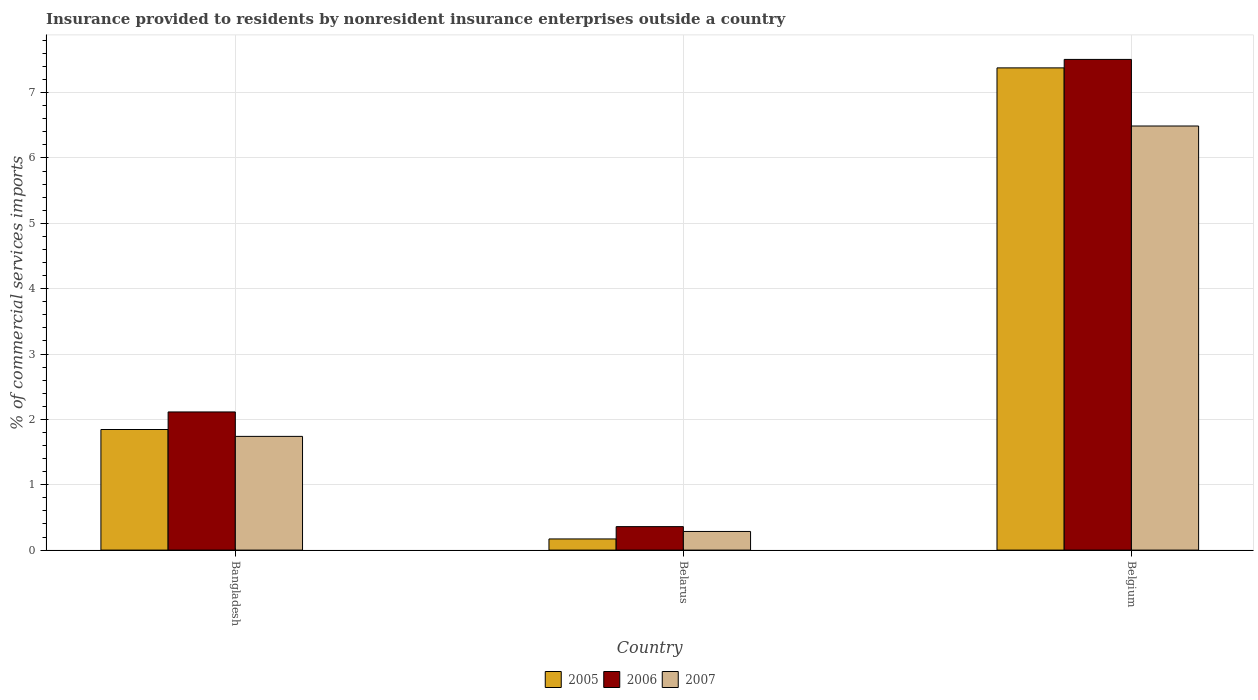How many different coloured bars are there?
Your answer should be very brief. 3. How many groups of bars are there?
Provide a succinct answer. 3. Are the number of bars on each tick of the X-axis equal?
Make the answer very short. Yes. How many bars are there on the 3rd tick from the left?
Your answer should be compact. 3. How many bars are there on the 2nd tick from the right?
Provide a succinct answer. 3. What is the label of the 2nd group of bars from the left?
Your response must be concise. Belarus. What is the Insurance provided to residents in 2007 in Bangladesh?
Provide a succinct answer. 1.74. Across all countries, what is the maximum Insurance provided to residents in 2006?
Provide a short and direct response. 7.51. Across all countries, what is the minimum Insurance provided to residents in 2006?
Keep it short and to the point. 0.36. In which country was the Insurance provided to residents in 2007 minimum?
Give a very brief answer. Belarus. What is the total Insurance provided to residents in 2005 in the graph?
Provide a short and direct response. 9.39. What is the difference between the Insurance provided to residents in 2006 in Bangladesh and that in Belarus?
Keep it short and to the point. 1.75. What is the difference between the Insurance provided to residents in 2006 in Bangladesh and the Insurance provided to residents in 2005 in Belgium?
Provide a short and direct response. -5.26. What is the average Insurance provided to residents in 2005 per country?
Give a very brief answer. 3.13. What is the difference between the Insurance provided to residents of/in 2007 and Insurance provided to residents of/in 2006 in Belarus?
Ensure brevity in your answer.  -0.07. What is the ratio of the Insurance provided to residents in 2005 in Belarus to that in Belgium?
Give a very brief answer. 0.02. Is the Insurance provided to residents in 2007 in Bangladesh less than that in Belgium?
Ensure brevity in your answer.  Yes. What is the difference between the highest and the second highest Insurance provided to residents in 2005?
Give a very brief answer. -1.67. What is the difference between the highest and the lowest Insurance provided to residents in 2007?
Ensure brevity in your answer.  6.2. Is the sum of the Insurance provided to residents in 2007 in Bangladesh and Belarus greater than the maximum Insurance provided to residents in 2005 across all countries?
Provide a short and direct response. No. What does the 3rd bar from the right in Belarus represents?
Offer a very short reply. 2005. Is it the case that in every country, the sum of the Insurance provided to residents in 2006 and Insurance provided to residents in 2005 is greater than the Insurance provided to residents in 2007?
Offer a very short reply. Yes. How many bars are there?
Your answer should be compact. 9. Are all the bars in the graph horizontal?
Your answer should be very brief. No. Are the values on the major ticks of Y-axis written in scientific E-notation?
Your response must be concise. No. Where does the legend appear in the graph?
Provide a short and direct response. Bottom center. How many legend labels are there?
Your answer should be compact. 3. How are the legend labels stacked?
Your response must be concise. Horizontal. What is the title of the graph?
Offer a very short reply. Insurance provided to residents by nonresident insurance enterprises outside a country. Does "1995" appear as one of the legend labels in the graph?
Your answer should be very brief. No. What is the label or title of the X-axis?
Your answer should be very brief. Country. What is the label or title of the Y-axis?
Make the answer very short. % of commercial services imports. What is the % of commercial services imports of 2005 in Bangladesh?
Your answer should be very brief. 1.85. What is the % of commercial services imports in 2006 in Bangladesh?
Provide a succinct answer. 2.11. What is the % of commercial services imports in 2007 in Bangladesh?
Give a very brief answer. 1.74. What is the % of commercial services imports of 2005 in Belarus?
Provide a short and direct response. 0.17. What is the % of commercial services imports of 2006 in Belarus?
Give a very brief answer. 0.36. What is the % of commercial services imports of 2007 in Belarus?
Provide a succinct answer. 0.29. What is the % of commercial services imports in 2005 in Belgium?
Your response must be concise. 7.38. What is the % of commercial services imports in 2006 in Belgium?
Offer a terse response. 7.51. What is the % of commercial services imports of 2007 in Belgium?
Offer a terse response. 6.49. Across all countries, what is the maximum % of commercial services imports in 2005?
Keep it short and to the point. 7.38. Across all countries, what is the maximum % of commercial services imports in 2006?
Provide a succinct answer. 7.51. Across all countries, what is the maximum % of commercial services imports of 2007?
Your answer should be compact. 6.49. Across all countries, what is the minimum % of commercial services imports in 2005?
Provide a short and direct response. 0.17. Across all countries, what is the minimum % of commercial services imports of 2006?
Provide a succinct answer. 0.36. Across all countries, what is the minimum % of commercial services imports of 2007?
Your response must be concise. 0.29. What is the total % of commercial services imports in 2005 in the graph?
Ensure brevity in your answer.  9.39. What is the total % of commercial services imports in 2006 in the graph?
Provide a short and direct response. 9.98. What is the total % of commercial services imports of 2007 in the graph?
Give a very brief answer. 8.51. What is the difference between the % of commercial services imports in 2005 in Bangladesh and that in Belarus?
Your answer should be very brief. 1.67. What is the difference between the % of commercial services imports of 2006 in Bangladesh and that in Belarus?
Your response must be concise. 1.75. What is the difference between the % of commercial services imports of 2007 in Bangladesh and that in Belarus?
Provide a short and direct response. 1.45. What is the difference between the % of commercial services imports in 2005 in Bangladesh and that in Belgium?
Make the answer very short. -5.53. What is the difference between the % of commercial services imports in 2006 in Bangladesh and that in Belgium?
Keep it short and to the point. -5.39. What is the difference between the % of commercial services imports of 2007 in Bangladesh and that in Belgium?
Your response must be concise. -4.75. What is the difference between the % of commercial services imports in 2005 in Belarus and that in Belgium?
Ensure brevity in your answer.  -7.21. What is the difference between the % of commercial services imports of 2006 in Belarus and that in Belgium?
Your response must be concise. -7.15. What is the difference between the % of commercial services imports of 2007 in Belarus and that in Belgium?
Provide a short and direct response. -6.2. What is the difference between the % of commercial services imports in 2005 in Bangladesh and the % of commercial services imports in 2006 in Belarus?
Provide a succinct answer. 1.49. What is the difference between the % of commercial services imports in 2005 in Bangladesh and the % of commercial services imports in 2007 in Belarus?
Your answer should be very brief. 1.56. What is the difference between the % of commercial services imports of 2006 in Bangladesh and the % of commercial services imports of 2007 in Belarus?
Your response must be concise. 1.83. What is the difference between the % of commercial services imports of 2005 in Bangladesh and the % of commercial services imports of 2006 in Belgium?
Your answer should be very brief. -5.66. What is the difference between the % of commercial services imports in 2005 in Bangladesh and the % of commercial services imports in 2007 in Belgium?
Your answer should be compact. -4.64. What is the difference between the % of commercial services imports of 2006 in Bangladesh and the % of commercial services imports of 2007 in Belgium?
Offer a very short reply. -4.38. What is the difference between the % of commercial services imports in 2005 in Belarus and the % of commercial services imports in 2006 in Belgium?
Give a very brief answer. -7.34. What is the difference between the % of commercial services imports of 2005 in Belarus and the % of commercial services imports of 2007 in Belgium?
Your answer should be compact. -6.32. What is the difference between the % of commercial services imports in 2006 in Belarus and the % of commercial services imports in 2007 in Belgium?
Offer a terse response. -6.13. What is the average % of commercial services imports in 2005 per country?
Provide a short and direct response. 3.13. What is the average % of commercial services imports of 2006 per country?
Give a very brief answer. 3.33. What is the average % of commercial services imports in 2007 per country?
Your answer should be compact. 2.84. What is the difference between the % of commercial services imports of 2005 and % of commercial services imports of 2006 in Bangladesh?
Your answer should be very brief. -0.27. What is the difference between the % of commercial services imports of 2005 and % of commercial services imports of 2007 in Bangladesh?
Your answer should be compact. 0.11. What is the difference between the % of commercial services imports in 2006 and % of commercial services imports in 2007 in Bangladesh?
Provide a succinct answer. 0.37. What is the difference between the % of commercial services imports of 2005 and % of commercial services imports of 2006 in Belarus?
Provide a short and direct response. -0.19. What is the difference between the % of commercial services imports of 2005 and % of commercial services imports of 2007 in Belarus?
Give a very brief answer. -0.11. What is the difference between the % of commercial services imports of 2006 and % of commercial services imports of 2007 in Belarus?
Your response must be concise. 0.07. What is the difference between the % of commercial services imports in 2005 and % of commercial services imports in 2006 in Belgium?
Your answer should be very brief. -0.13. What is the difference between the % of commercial services imports of 2005 and % of commercial services imports of 2007 in Belgium?
Provide a succinct answer. 0.89. What is the difference between the % of commercial services imports in 2006 and % of commercial services imports in 2007 in Belgium?
Provide a short and direct response. 1.02. What is the ratio of the % of commercial services imports in 2005 in Bangladesh to that in Belarus?
Your response must be concise. 10.81. What is the ratio of the % of commercial services imports of 2006 in Bangladesh to that in Belarus?
Ensure brevity in your answer.  5.89. What is the ratio of the % of commercial services imports in 2007 in Bangladesh to that in Belarus?
Give a very brief answer. 6.1. What is the ratio of the % of commercial services imports in 2005 in Bangladesh to that in Belgium?
Offer a very short reply. 0.25. What is the ratio of the % of commercial services imports in 2006 in Bangladesh to that in Belgium?
Ensure brevity in your answer.  0.28. What is the ratio of the % of commercial services imports in 2007 in Bangladesh to that in Belgium?
Provide a short and direct response. 0.27. What is the ratio of the % of commercial services imports of 2005 in Belarus to that in Belgium?
Provide a short and direct response. 0.02. What is the ratio of the % of commercial services imports in 2006 in Belarus to that in Belgium?
Your answer should be compact. 0.05. What is the ratio of the % of commercial services imports of 2007 in Belarus to that in Belgium?
Provide a succinct answer. 0.04. What is the difference between the highest and the second highest % of commercial services imports in 2005?
Your answer should be very brief. 5.53. What is the difference between the highest and the second highest % of commercial services imports of 2006?
Offer a terse response. 5.39. What is the difference between the highest and the second highest % of commercial services imports in 2007?
Your answer should be compact. 4.75. What is the difference between the highest and the lowest % of commercial services imports of 2005?
Your answer should be compact. 7.21. What is the difference between the highest and the lowest % of commercial services imports of 2006?
Make the answer very short. 7.15. What is the difference between the highest and the lowest % of commercial services imports in 2007?
Offer a very short reply. 6.2. 